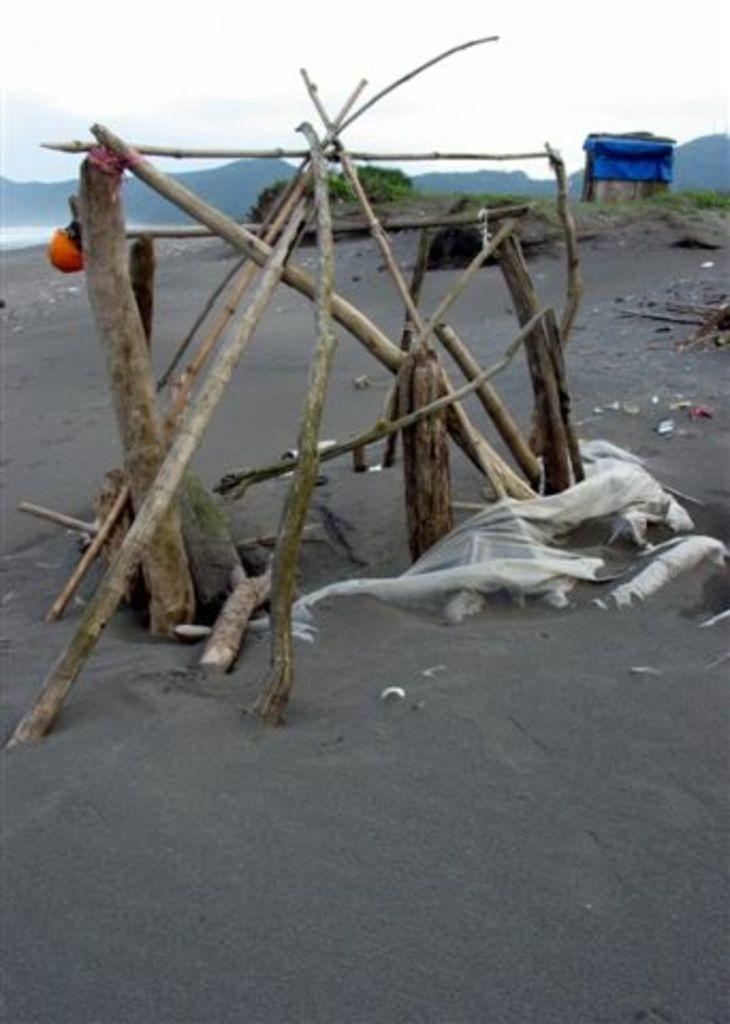What objects can be seen in the image? There are sticks and clothes on the ground visible in the image. What type of surface is visible in the background of the image? There is grass visible in the background of the image. What color is the blue object in the background of the image? The blue object in the background of the image is not described in the facts, so we cannot determine its color. What type of voice can be heard coming from the clothes in the image? There is no voice present in the image, as it is a still image and not a video or audio recording. 